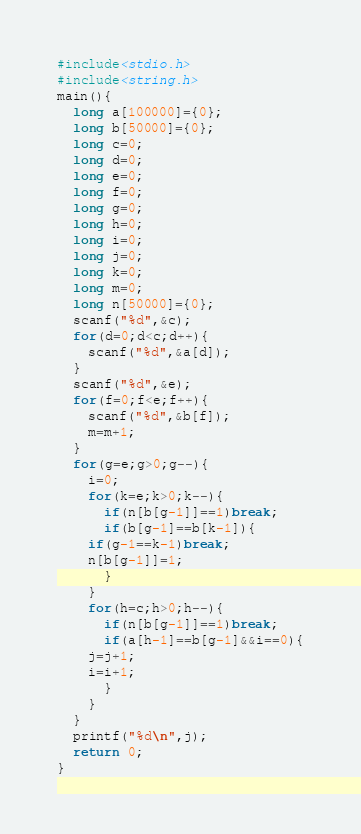Convert code to text. <code><loc_0><loc_0><loc_500><loc_500><_C_>#include<stdio.h>
#include<string.h>
main(){
  long a[100000]={0};
  long b[50000]={0};
  long c=0;
  long d=0;
  long e=0;
  long f=0;
  long g=0;
  long h=0;
  long i=0;
  long j=0;
  long k=0;
  long m=0;
  long n[50000]={0};
  scanf("%d",&c);
  for(d=0;d<c;d++){
    scanf("%d",&a[d]);
  }
  scanf("%d",&e);
  for(f=0;f<e;f++){
    scanf("%d",&b[f]);
    m=m+1;
  }
  for(g=e;g>0;g--){
    i=0;
    for(k=e;k>0;k--){
      if(n[b[g-1]]==1)break;
      if(b[g-1]==b[k-1]){
	if(g-1==k-1)break;
	n[b[g-1]]=1;
      }
    }
    for(h=c;h>0;h--){
      if(n[b[g-1]]==1)break;
      if(a[h-1]==b[g-1]&&i==0){
	j=j+1;
	i=i+1;
      }
    }
  }
  printf("%d\n",j);
  return 0;
}</code> 